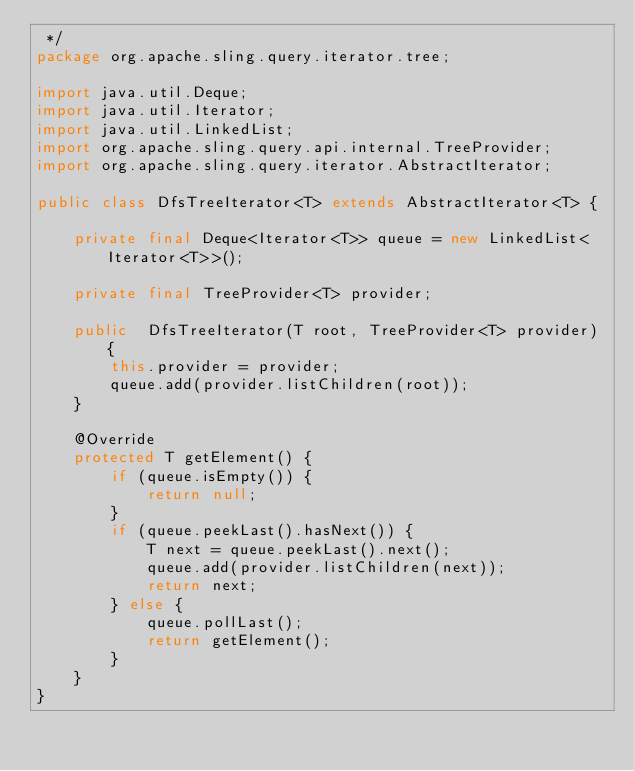Convert code to text. <code><loc_0><loc_0><loc_500><loc_500><_Java_> */
package org.apache.sling.query.iterator.tree;

import java.util.Deque;
import java.util.Iterator;
import java.util.LinkedList;
import org.apache.sling.query.api.internal.TreeProvider;
import org.apache.sling.query.iterator.AbstractIterator;

public class DfsTreeIterator<T> extends AbstractIterator<T> {

    private final Deque<Iterator<T>> queue = new LinkedList<Iterator<T>>();

    private final TreeProvider<T> provider;

    public  DfsTreeIterator(T root, TreeProvider<T> provider) {
        this.provider = provider;
        queue.add(provider.listChildren(root));
    }

    @Override
    protected T getElement() {
        if (queue.isEmpty()) {
            return null;
        }
        if (queue.peekLast().hasNext()) {
            T next = queue.peekLast().next();
            queue.add(provider.listChildren(next));
            return next;
        } else {
            queue.pollLast();
            return getElement();
        }
    }
}
</code> 